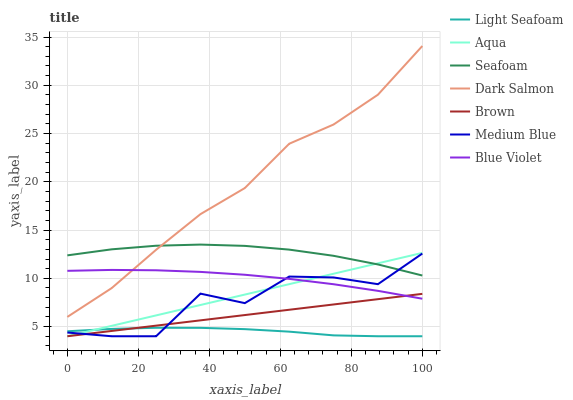Does Light Seafoam have the minimum area under the curve?
Answer yes or no. Yes. Does Dark Salmon have the maximum area under the curve?
Answer yes or no. Yes. Does Aqua have the minimum area under the curve?
Answer yes or no. No. Does Aqua have the maximum area under the curve?
Answer yes or no. No. Is Aqua the smoothest?
Answer yes or no. Yes. Is Medium Blue the roughest?
Answer yes or no. Yes. Is Medium Blue the smoothest?
Answer yes or no. No. Is Aqua the roughest?
Answer yes or no. No. Does Brown have the lowest value?
Answer yes or no. Yes. Does Seafoam have the lowest value?
Answer yes or no. No. Does Dark Salmon have the highest value?
Answer yes or no. Yes. Does Aqua have the highest value?
Answer yes or no. No. Is Brown less than Dark Salmon?
Answer yes or no. Yes. Is Dark Salmon greater than Light Seafoam?
Answer yes or no. Yes. Does Medium Blue intersect Light Seafoam?
Answer yes or no. Yes. Is Medium Blue less than Light Seafoam?
Answer yes or no. No. Is Medium Blue greater than Light Seafoam?
Answer yes or no. No. Does Brown intersect Dark Salmon?
Answer yes or no. No. 